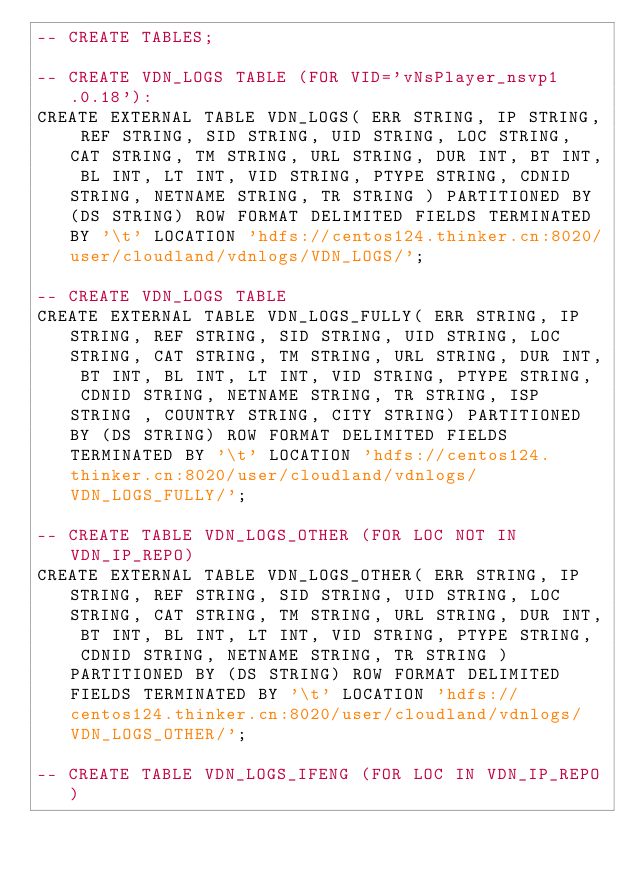<code> <loc_0><loc_0><loc_500><loc_500><_SQL_>-- CREATE TABLES;

-- CREATE VDN_LOGS TABLE (FOR VID='vNsPlayer_nsvp1.0.18'):
CREATE EXTERNAL TABLE VDN_LOGS( ERR STRING, IP STRING, REF STRING, SID STRING, UID STRING, LOC STRING, CAT STRING, TM STRING, URL STRING, DUR INT, BT INT, BL INT, LT INT, VID STRING, PTYPE STRING, CDNID STRING, NETNAME STRING, TR STRING ) PARTITIONED BY (DS STRING) ROW FORMAT DELIMITED FIELDS TERMINATED BY '\t' LOCATION 'hdfs://centos124.thinker.cn:8020/user/cloudland/vdnlogs/VDN_LOGS/'; 

-- CREATE VDN_LOGS TABLE 
CREATE EXTERNAL TABLE VDN_LOGS_FULLY( ERR STRING, IP STRING, REF STRING, SID STRING, UID STRING, LOC STRING, CAT STRING, TM STRING, URL STRING, DUR INT, BT INT, BL INT, LT INT, VID STRING, PTYPE STRING,  CDNID STRING, NETNAME STRING, TR STRING, ISP STRING , COUNTRY STRING, CITY STRING) PARTITIONED BY (DS STRING) ROW FORMAT DELIMITED FIELDS TERMINATED BY '\t' LOCATION 'hdfs://centos124.thinker.cn:8020/user/cloudland/vdnlogs/VDN_LOGS_FULLY/'; 

-- CREATE TABLE VDN_LOGS_OTHER (FOR LOC NOT IN VDN_IP_REPO)
CREATE EXTERNAL TABLE VDN_LOGS_OTHER( ERR STRING, IP STRING, REF STRING, SID STRING, UID STRING, LOC STRING, CAT STRING, TM STRING, URL STRING, DUR INT, BT INT, BL INT, LT INT, VID STRING, PTYPE STRING,  CDNID STRING, NETNAME STRING, TR STRING ) PARTITIONED BY (DS STRING) ROW FORMAT DELIMITED FIELDS TERMINATED BY '\t' LOCATION 'hdfs://centos124.thinker.cn:8020/user/cloudland/vdnlogs/VDN_LOGS_OTHER/'; 

-- CREATE TABLE VDN_LOGS_IFENG (FOR LOC IN VDN_IP_REPO)</code> 